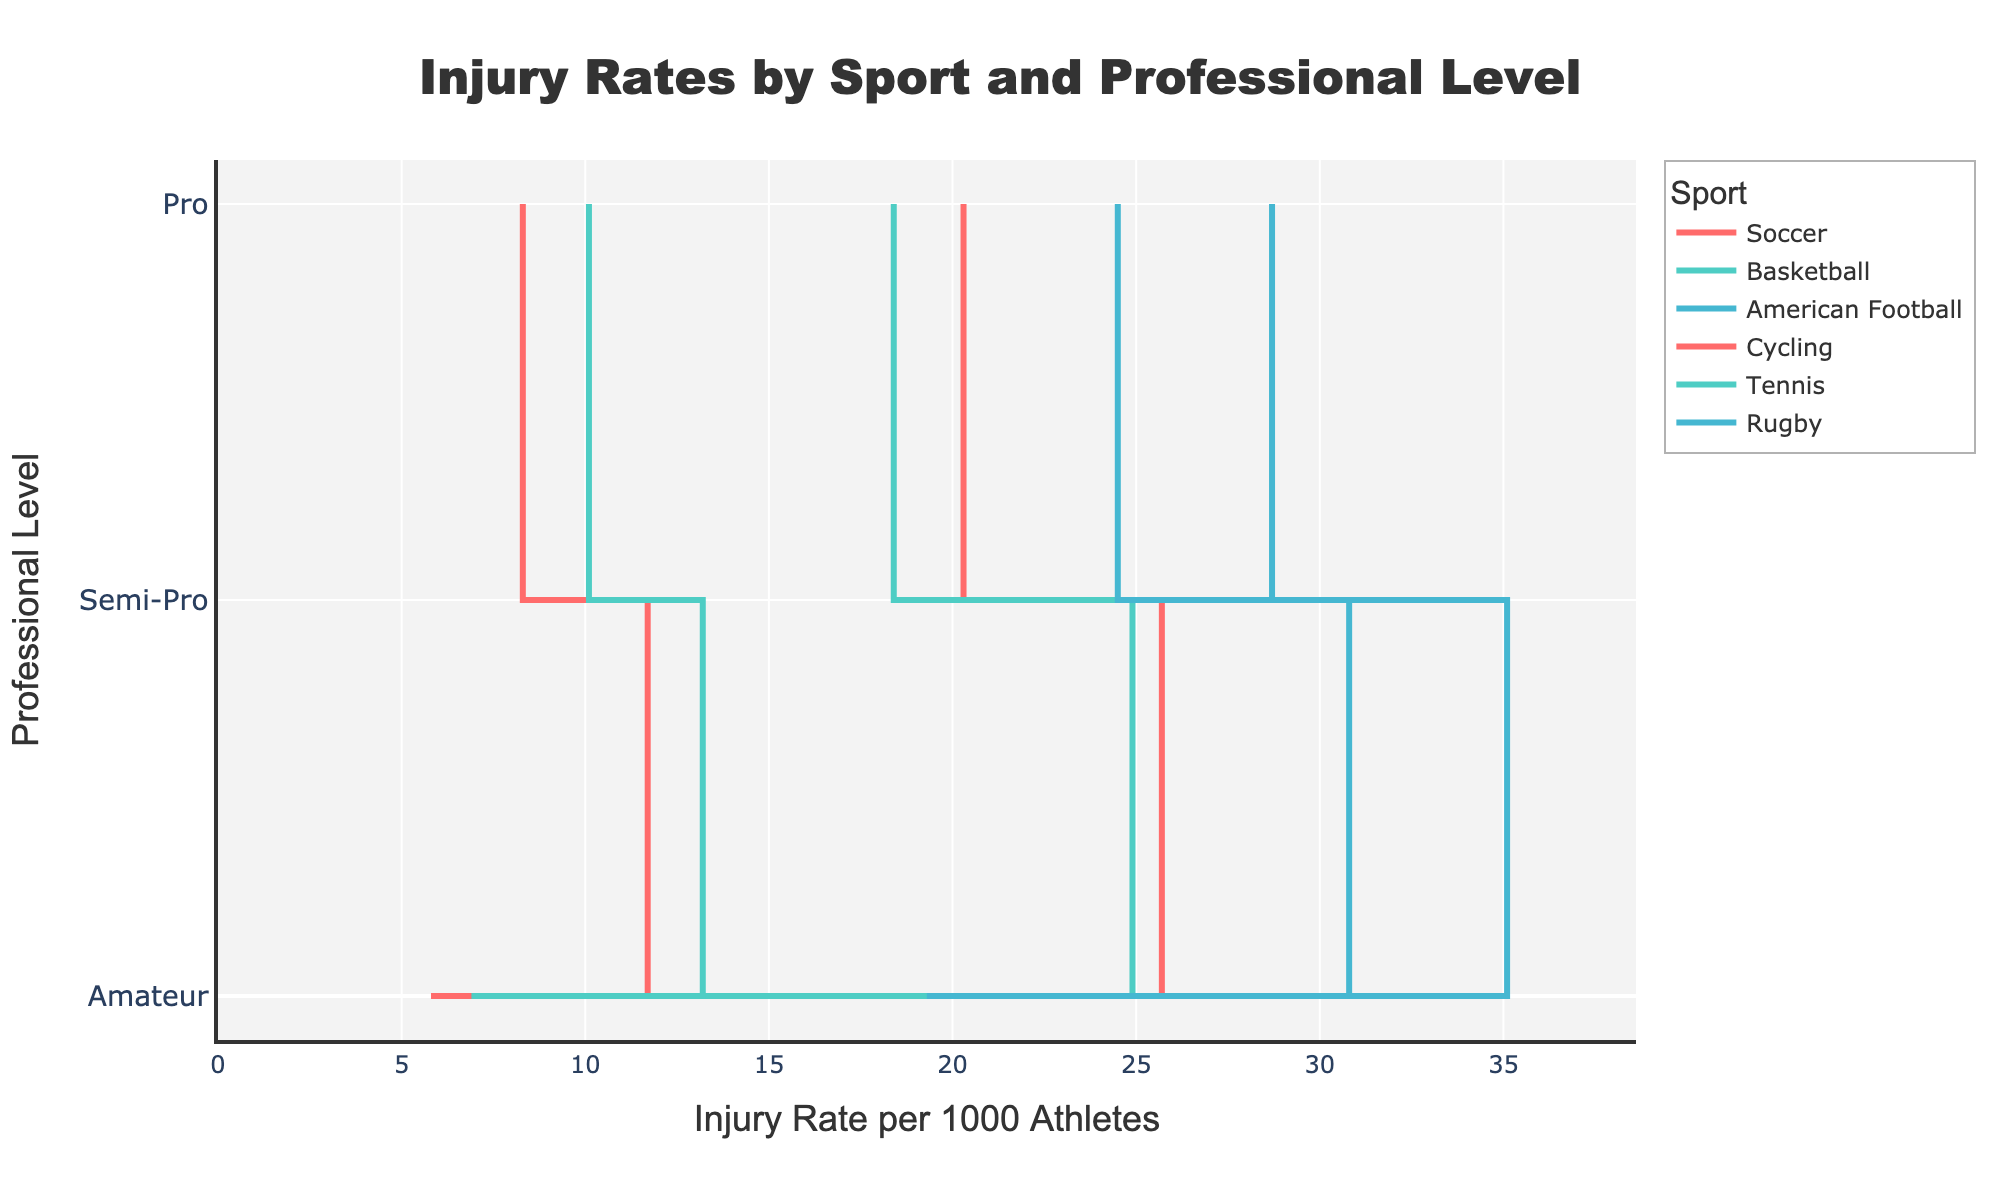What's the title of the plot? The title is prominently displayed at the top of the figure in larger font size and bold style: "Injury Rates by Sport and Professional Level".
Answer: "Injury Rates by Sport and Professional Level" Which sport has the highest injury rate at the professional level? To determine this, examine the highest data point on the 'Pro' level for all sports. American Football at the professional level has the highest injury rate, shown to be 35.1 per 1000 athletes.
Answer: American Football What is the trend of injury rates in cycling from amateur to professional level? To understand the trend, follow the line for cycling from amateur to semi-pro to pro. The injury rates steadily increase from 5.8 at amateur to 8.3 at semi-pro to 11.7 at pro.
Answer: Increasing Compare the injury rates between amateur soccer and amateur rugby. Which is higher? Compare the points corresponding to amateur levels for both soccer and rugby. Soccer has an injury rate of 15.2 while Rugby has an injury rate of 19.3.
Answer: Rugby Is the increase in injury rate from amateur to pro level more significant in basketball or tennis? Calculate the increase for each sport: Basketball increases from 12.6 to 24.9, a difference of 12.3. Tennis increases from 6.9 to 13.2, a difference of 6.3. Therefore, the increase is more significant in basketball.
Answer: Basketball What sport has the smallest range in injury rates from amateur to pro level? Calculate the range for each sport by subtracting the amateur rate from the pro rate. The ranges are: Soccer: 10.5, Basketball: 12.3, American Football: 12.6, Cycling: 5.9, Tennis: 6.3, Rugby: 11.5. Cycling has the smallest range.
Answer: Cycling On average, which professional level has the highest injury rates across all sports? Compute the average injury rate for each level by summing the injury rates for all sports at each level and dividing by the number of sports: Amateur: (15.2+12.6+22.5+5.8+6.9+19.3)/6 = 13.8, Semi-Pro: (20.3+18.4+28.7+8.3+10.1+24.5)/6 = 18.4, Pro: (25.7+24.9+35.1+11.7+13.2+30.8)/6 = 23.6. The Pro level has the highest average injury rates.
Answer: Pro 